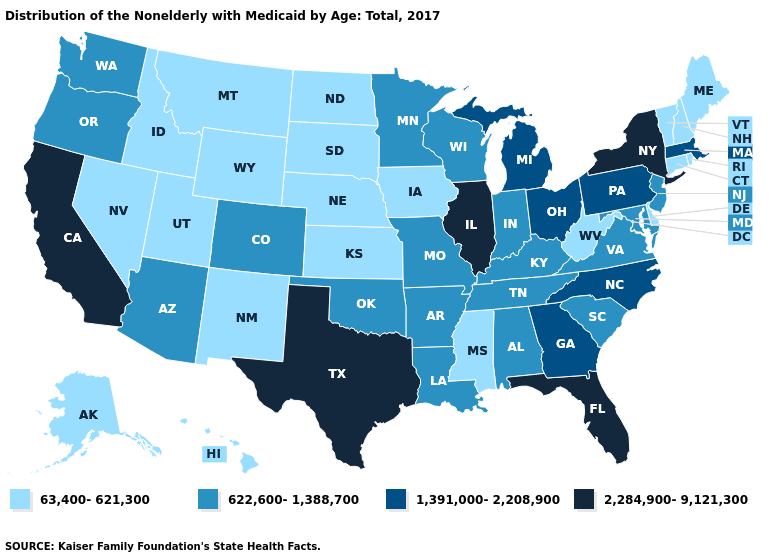Does Florida have the highest value in the USA?
Answer briefly. Yes. What is the value of Iowa?
Short answer required. 63,400-621,300. Does Michigan have a higher value than North Dakota?
Write a very short answer. Yes. What is the lowest value in the USA?
Answer briefly. 63,400-621,300. Does the map have missing data?
Concise answer only. No. Among the states that border Maryland , does West Virginia have the lowest value?
Give a very brief answer. Yes. Does California have a higher value than Texas?
Keep it brief. No. Among the states that border Indiana , which have the highest value?
Keep it brief. Illinois. Name the states that have a value in the range 63,400-621,300?
Quick response, please. Alaska, Connecticut, Delaware, Hawaii, Idaho, Iowa, Kansas, Maine, Mississippi, Montana, Nebraska, Nevada, New Hampshire, New Mexico, North Dakota, Rhode Island, South Dakota, Utah, Vermont, West Virginia, Wyoming. Is the legend a continuous bar?
Short answer required. No. Does Tennessee have the highest value in the USA?
Keep it brief. No. Name the states that have a value in the range 2,284,900-9,121,300?
Be succinct. California, Florida, Illinois, New York, Texas. What is the value of South Carolina?
Answer briefly. 622,600-1,388,700. What is the value of Alaska?
Concise answer only. 63,400-621,300. What is the lowest value in the USA?
Keep it brief. 63,400-621,300. 